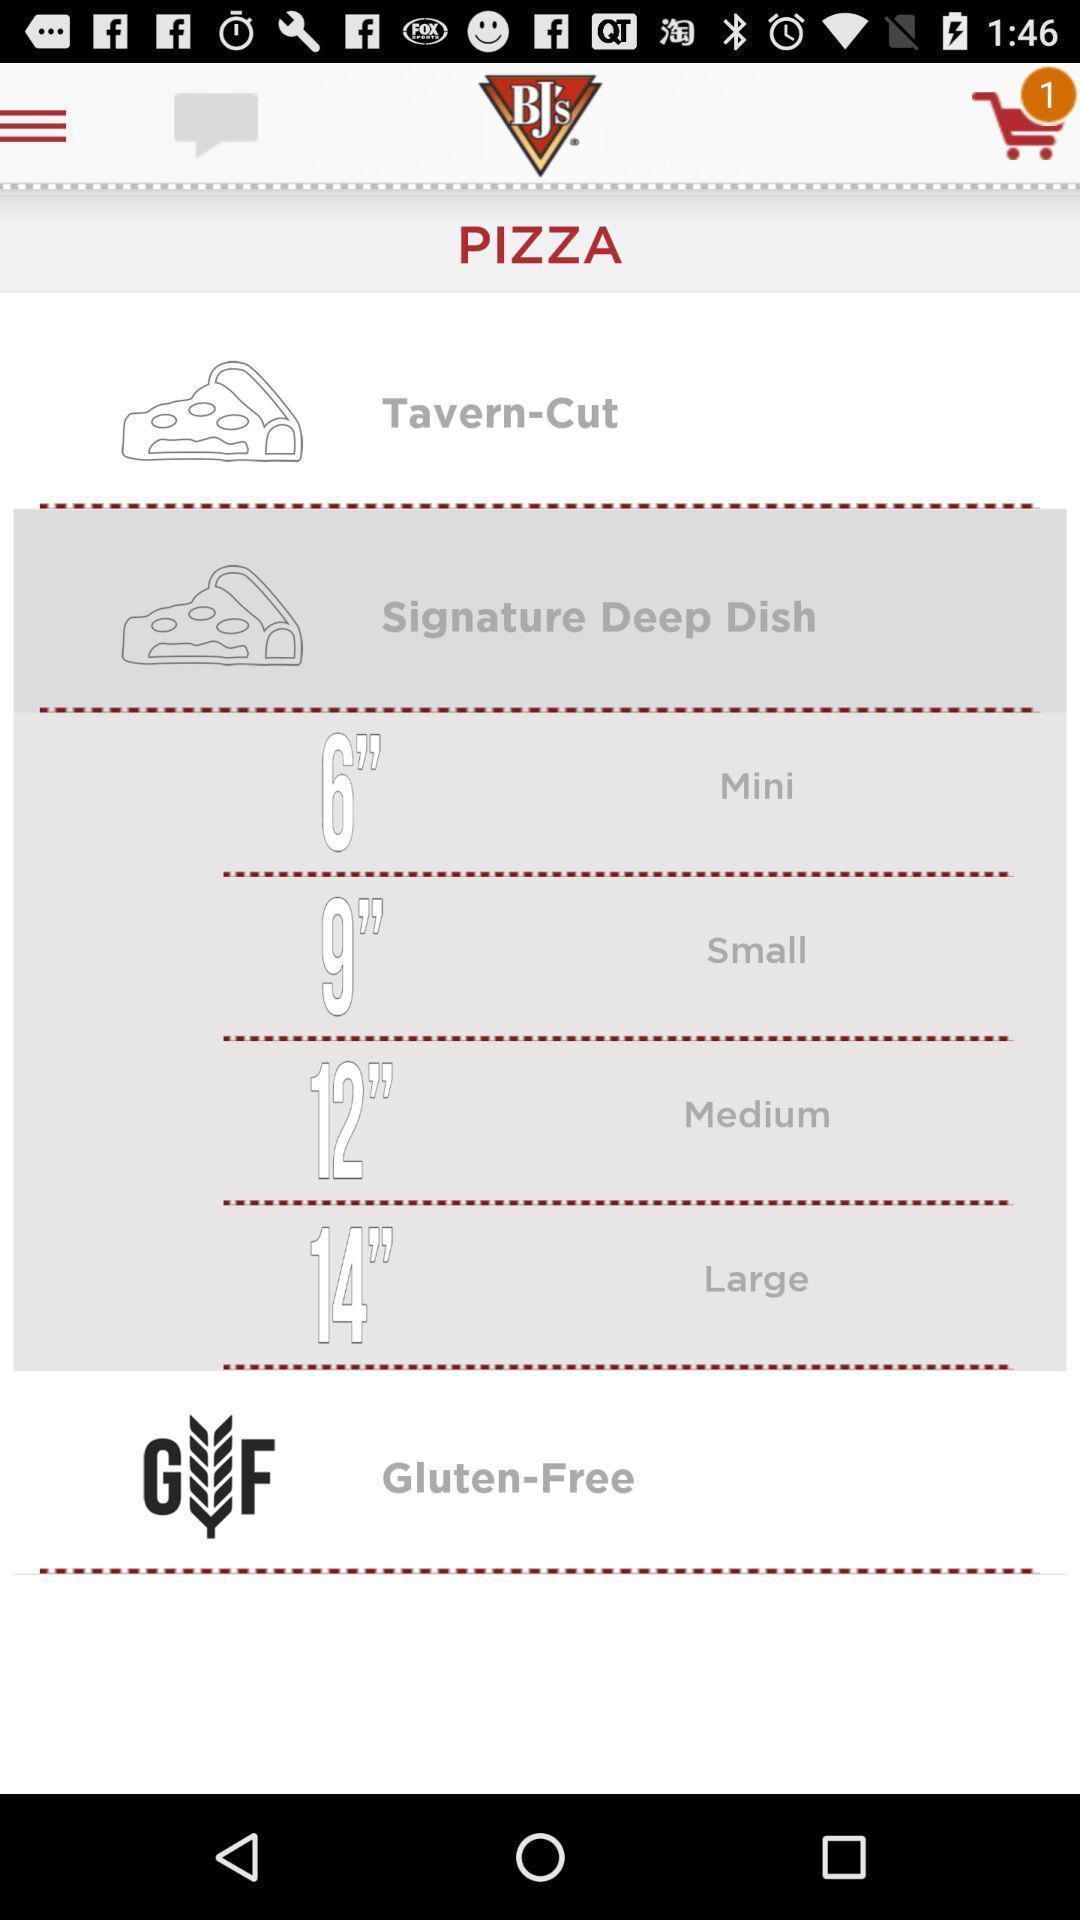What details can you identify in this image? Screen page of a food application. 